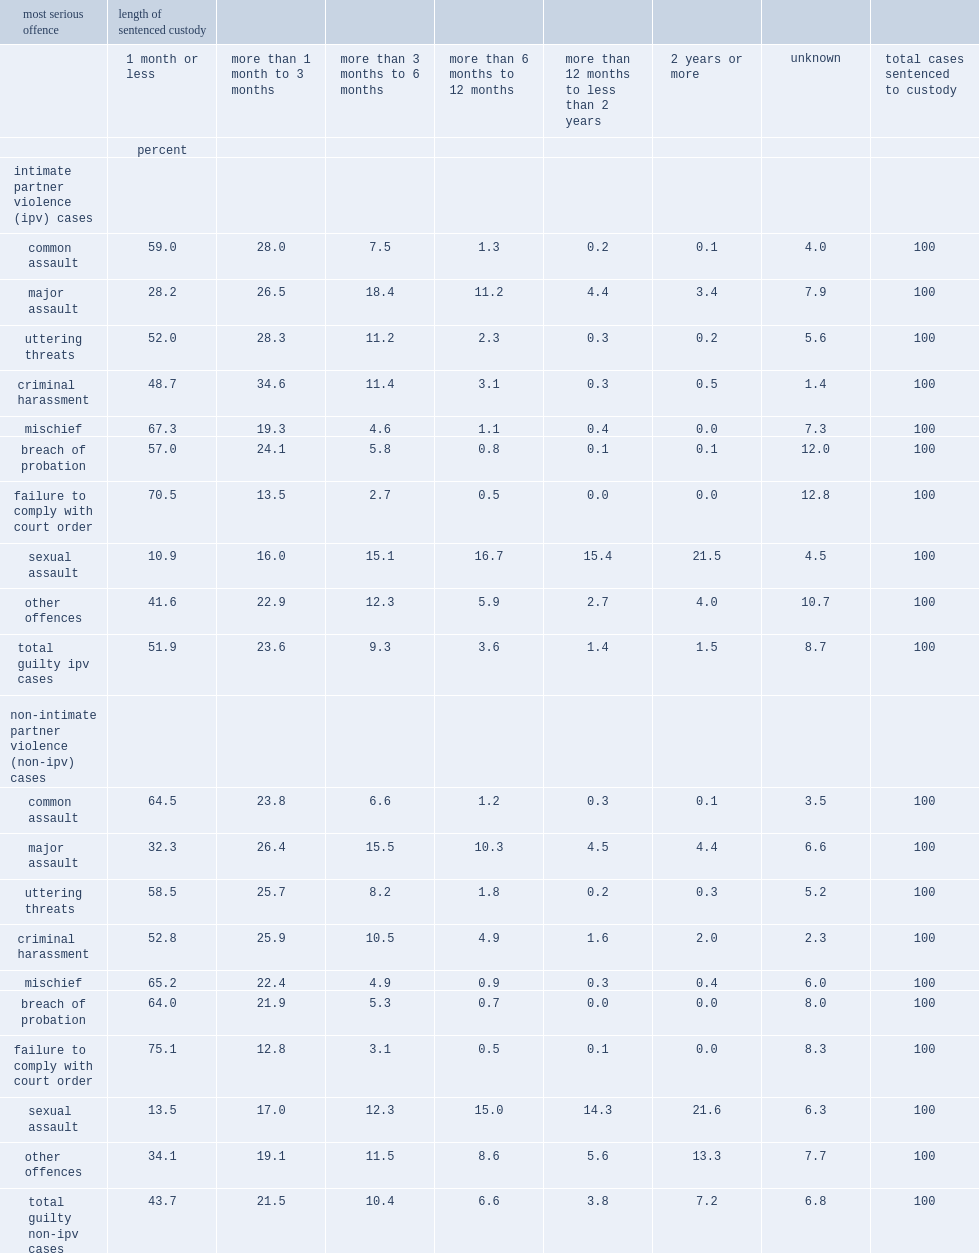What percent of those imposed in ipv cases has sentenced to custody for six months or less? 84.8. What percent of the persons convicted in ipv cases has sentenced custody for one month or less? 51.9. What percent of convicted ipv cases , sentences were between six months and one year less a day? 3.6. What percent of those found guilty in ipv cases were sentenced to more than one year in custody? 2.9. Give me the full table as a dictionary. {'header': ['most serious offence', 'length of sentenced custody', '', '', '', '', '', '', ''], 'rows': [['', '1 month or less', 'more than 1 month to 3 months', 'more than 3 months to 6 months', 'more than 6 months to 12 months', 'more than 12 months to less than 2 years', '2 years or more', 'unknown', 'total cases sentenced to custody'], ['', 'percent', '', '', '', '', '', '', ''], ['intimate partner violence (ipv) cases', '', '', '', '', '', '', '', ''], ['common assault', '59.0', '28.0', '7.5', '1.3', '0.2', '0.1', '4.0', '100'], ['major assault', '28.2', '26.5', '18.4', '11.2', '4.4', '3.4', '7.9', '100'], ['uttering threats', '52.0', '28.3', '11.2', '2.3', '0.3', '0.2', '5.6', '100'], ['criminal harassment', '48.7', '34.6', '11.4', '3.1', '0.3', '0.5', '1.4', '100'], ['mischief', '67.3', '19.3', '4.6', '1.1', '0.4', '0.0', '7.3', '100'], ['breach of probation', '57.0', '24.1', '5.8', '0.8', '0.1', '0.1', '12.0', '100'], ['failure to comply with court order', '70.5', '13.5', '2.7', '0.5', '0.0', '0.0', '12.8', '100'], ['sexual assault', '10.9', '16.0', '15.1', '16.7', '15.4', '21.5', '4.5', '100'], ['other offences', '41.6', '22.9', '12.3', '5.9', '2.7', '4.0', '10.7', '100'], ['total guilty ipv cases', '51.9', '23.6', '9.3', '3.6', '1.4', '1.5', '8.7', '100'], ['non-intimate partner violence (non-ipv) cases', '', '', '', '', '', '', '', ''], ['common assault', '64.5', '23.8', '6.6', '1.2', '0.3', '0.1', '3.5', '100'], ['major assault', '32.3', '26.4', '15.5', '10.3', '4.5', '4.4', '6.6', '100'], ['uttering threats', '58.5', '25.7', '8.2', '1.8', '0.2', '0.3', '5.2', '100'], ['criminal harassment', '52.8', '25.9', '10.5', '4.9', '1.6', '2.0', '2.3', '100'], ['mischief', '65.2', '22.4', '4.9', '0.9', '0.3', '0.4', '6.0', '100'], ['breach of probation', '64.0', '21.9', '5.3', '0.7', '0.0', '0.0', '8.0', '100'], ['failure to comply with court order', '75.1', '12.8', '3.1', '0.5', '0.1', '0.0', '8.3', '100'], ['sexual assault', '13.5', '17.0', '12.3', '15.0', '14.3', '21.6', '6.3', '100'], ['other offences', '34.1', '19.1', '11.5', '8.6', '5.6', '13.3', '7.7', '100'], ['total guilty non-ipv cases', '43.7', '21.5', '10.4', '6.6', '3.8', '7.2', '6.8', '100']]} 